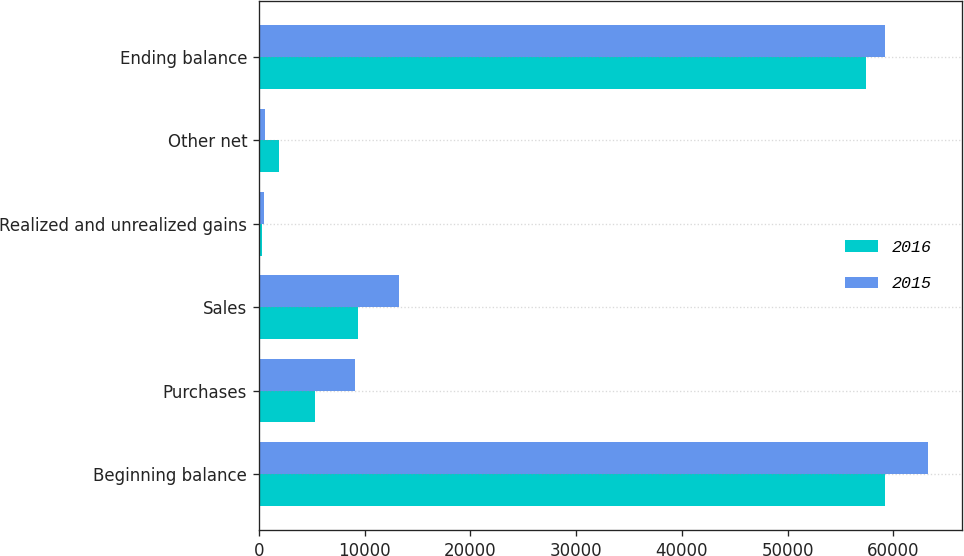Convert chart to OTSL. <chart><loc_0><loc_0><loc_500><loc_500><stacked_bar_chart><ecel><fcel>Beginning balance<fcel>Purchases<fcel>Sales<fcel>Realized and unrealized gains<fcel>Other net<fcel>Ending balance<nl><fcel>2016<fcel>59186<fcel>5355<fcel>9354<fcel>344<fcel>1913<fcel>57444<nl><fcel>2015<fcel>63315<fcel>9062<fcel>13252<fcel>501<fcel>562<fcel>59186<nl></chart> 